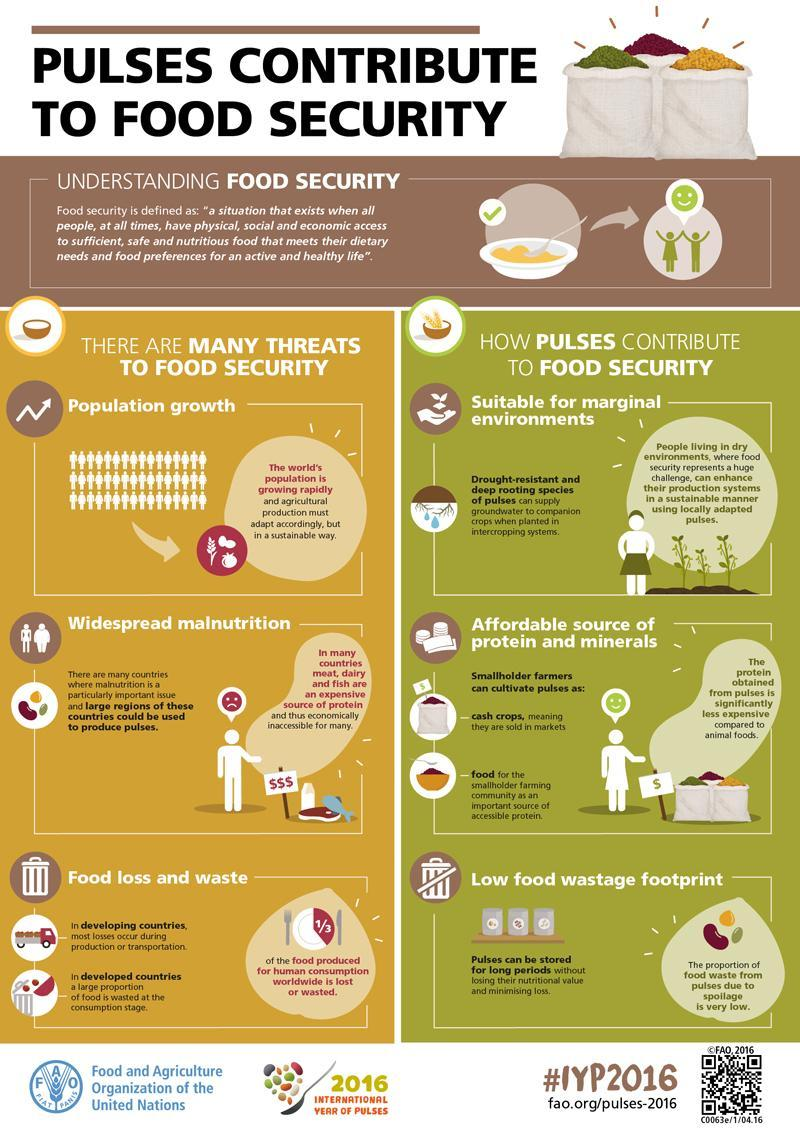What is the first and most major threat to  food security?
Answer the question with a short phrase. Population Growth 